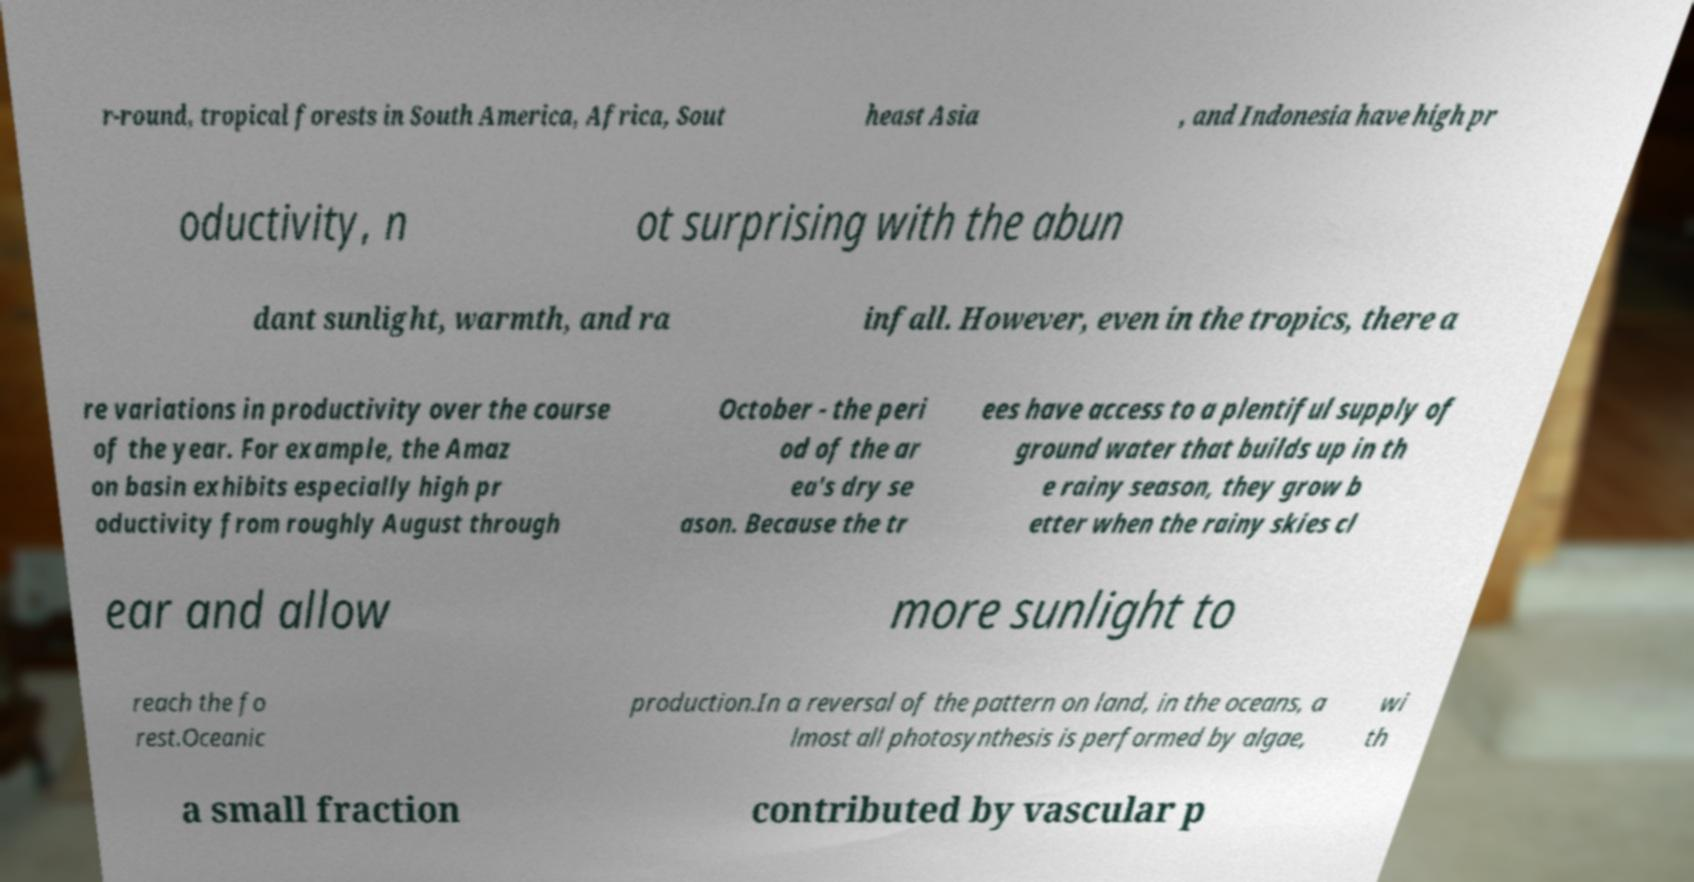Could you assist in decoding the text presented in this image and type it out clearly? r-round, tropical forests in South America, Africa, Sout heast Asia , and Indonesia have high pr oductivity, n ot surprising with the abun dant sunlight, warmth, and ra infall. However, even in the tropics, there a re variations in productivity over the course of the year. For example, the Amaz on basin exhibits especially high pr oductivity from roughly August through October - the peri od of the ar ea's dry se ason. Because the tr ees have access to a plentiful supply of ground water that builds up in th e rainy season, they grow b etter when the rainy skies cl ear and allow more sunlight to reach the fo rest.Oceanic production.In a reversal of the pattern on land, in the oceans, a lmost all photosynthesis is performed by algae, wi th a small fraction contributed by vascular p 